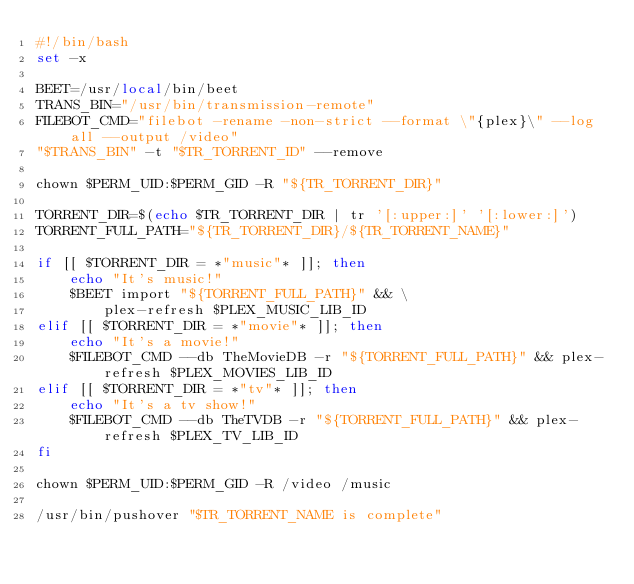<code> <loc_0><loc_0><loc_500><loc_500><_Bash_>#!/bin/bash
set -x

BEET=/usr/local/bin/beet
TRANS_BIN="/usr/bin/transmission-remote"
FILEBOT_CMD="filebot -rename -non-strict --format \"{plex}\" --log all --output /video"
"$TRANS_BIN" -t "$TR_TORRENT_ID" --remove

chown $PERM_UID:$PERM_GID -R "${TR_TORRENT_DIR}"

TORRENT_DIR=$(echo $TR_TORRENT_DIR | tr '[:upper:]' '[:lower:]')
TORRENT_FULL_PATH="${TR_TORRENT_DIR}/${TR_TORRENT_NAME}"

if [[ $TORRENT_DIR = *"music"* ]]; then
    echo "It's music!"
    $BEET import "${TORRENT_FULL_PATH}" && \
        plex-refresh $PLEX_MUSIC_LIB_ID
elif [[ $TORRENT_DIR = *"movie"* ]]; then
    echo "It's a movie!"
    $FILEBOT_CMD --db TheMovieDB -r "${TORRENT_FULL_PATH}" && plex-refresh $PLEX_MOVIES_LIB_ID
elif [[ $TORRENT_DIR = *"tv"* ]]; then
    echo "It's a tv show!"
    $FILEBOT_CMD --db TheTVDB -r "${TORRENT_FULL_PATH}" && plex-refresh $PLEX_TV_LIB_ID
fi

chown $PERM_UID:$PERM_GID -R /video /music

/usr/bin/pushover "$TR_TORRENT_NAME is complete"
</code> 